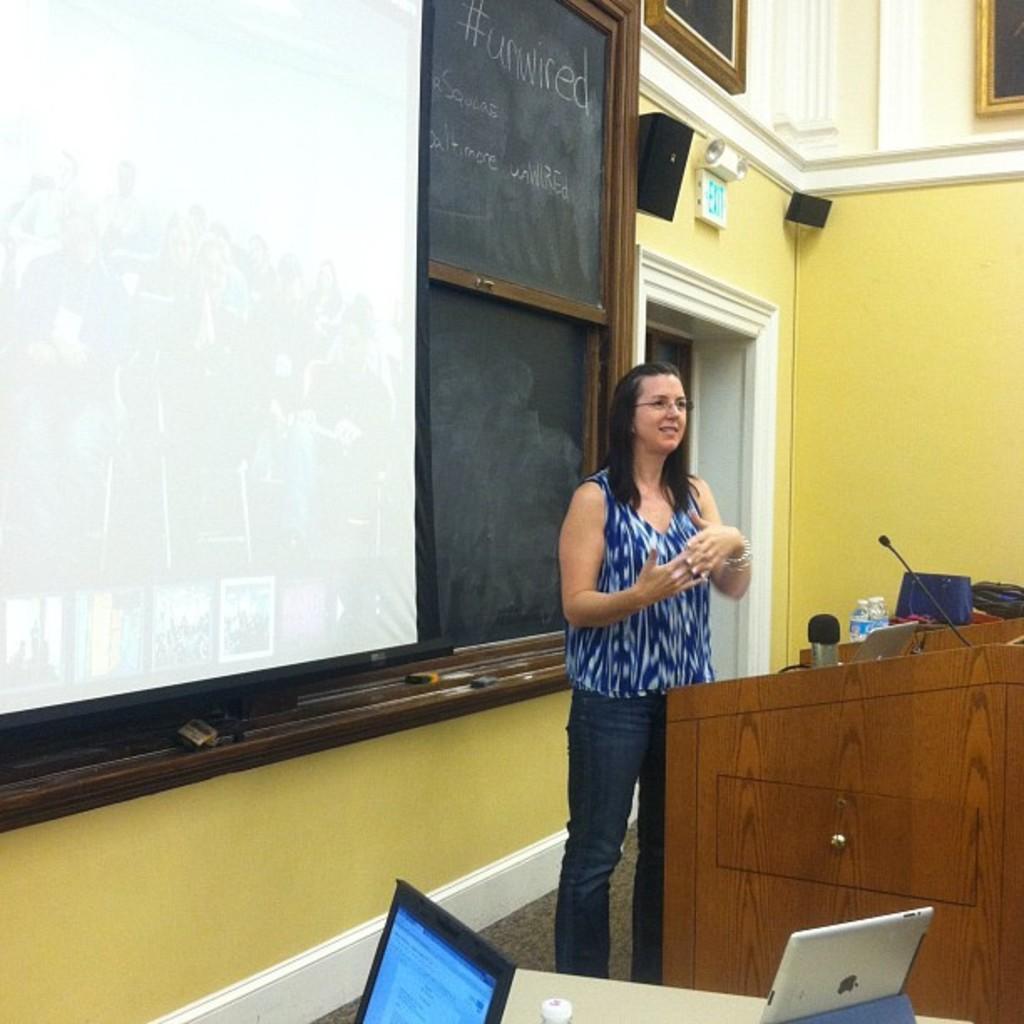In one or two sentences, can you explain what this image depicts? This picture might be taken in a classroom, in this picture in the center there is one woman who is standing and she is smiling in front of there are some tables, mike, bottles and some other objects. At the bottom there are two laptops on a table, and on the left side there is one board on the wall. At the top of the image there are two windows, speaker and some objects on the wall. 